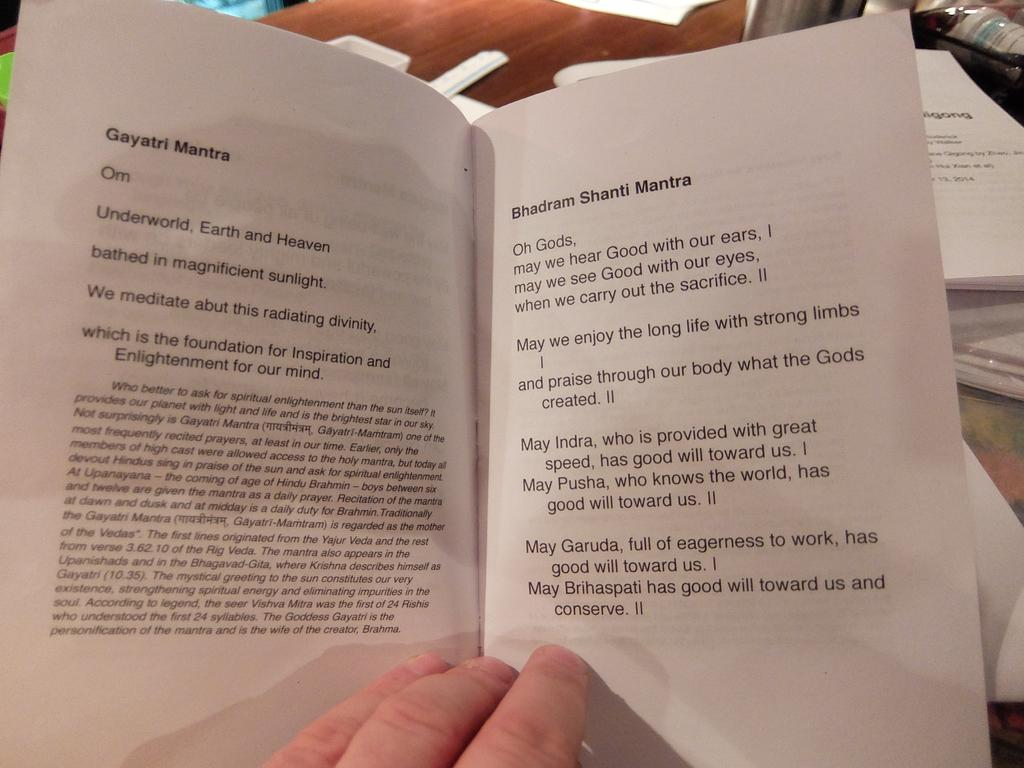<image>
Give a short and clear explanation of the subsequent image. A book open to Gayatri Mantra and Bhadram Shanti Mantra pages. 